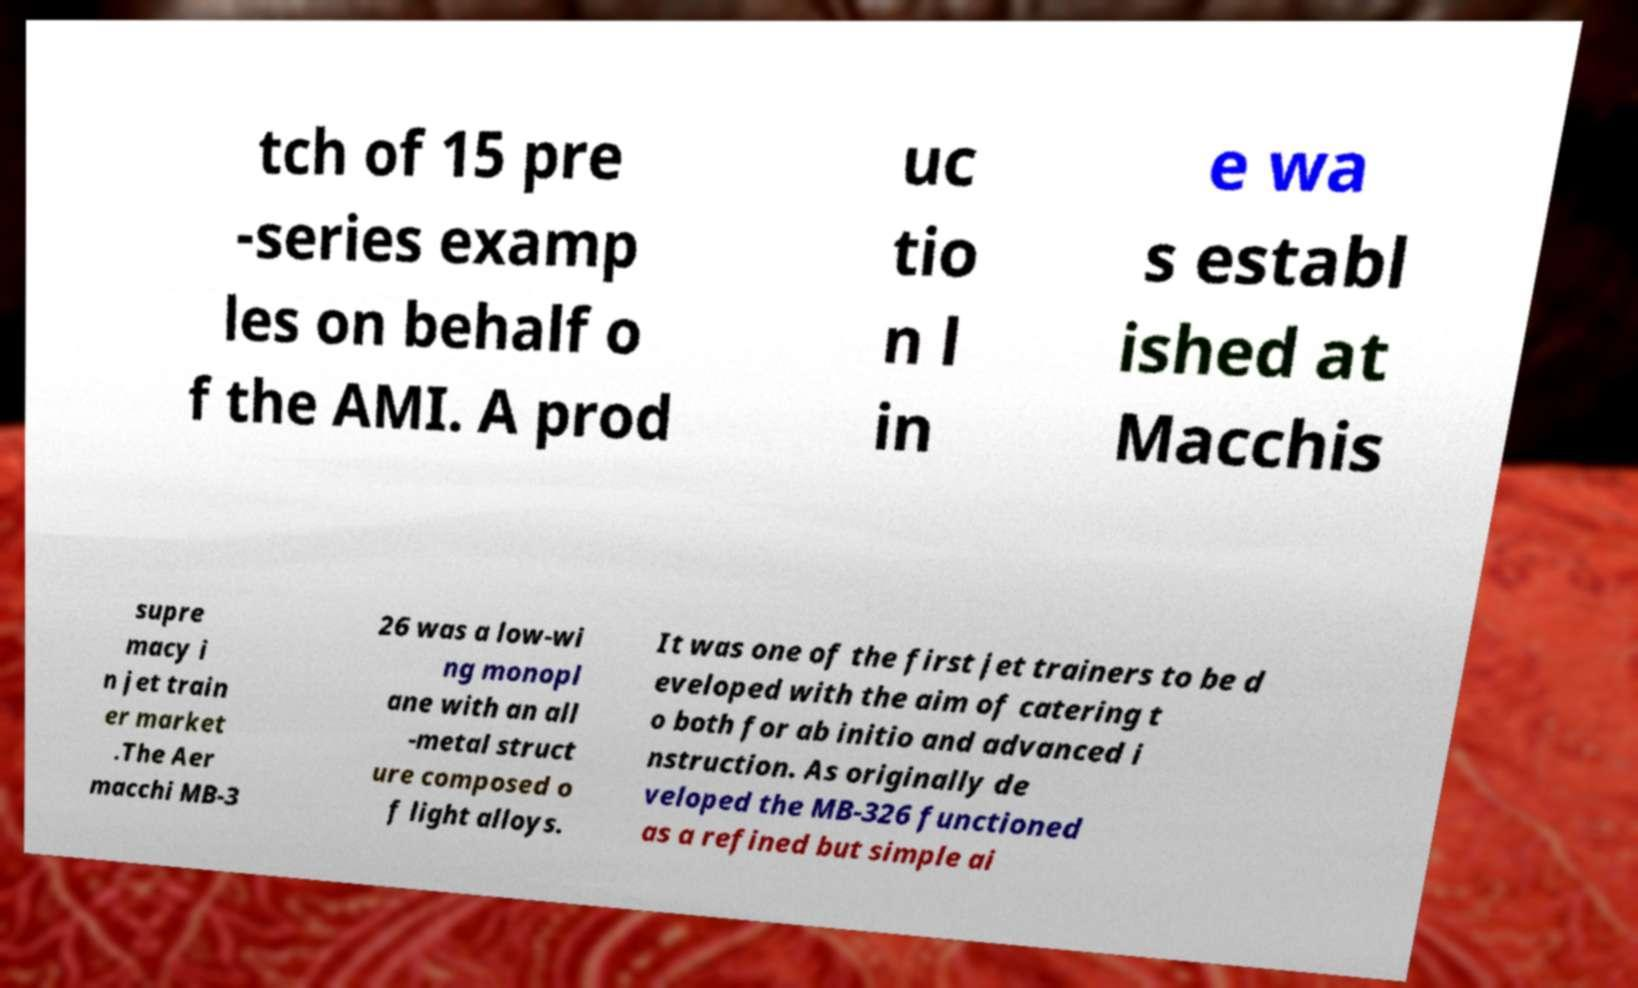Can you accurately transcribe the text from the provided image for me? tch of 15 pre -series examp les on behalf o f the AMI. A prod uc tio n l in e wa s establ ished at Macchis supre macy i n jet train er market .The Aer macchi MB-3 26 was a low-wi ng monopl ane with an all -metal struct ure composed o f light alloys. It was one of the first jet trainers to be d eveloped with the aim of catering t o both for ab initio and advanced i nstruction. As originally de veloped the MB-326 functioned as a refined but simple ai 